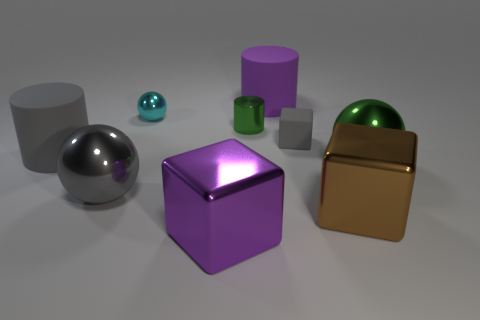Subtract all shiny cubes. How many cubes are left? 1 Subtract all gray cubes. How many cubes are left? 2 Subtract 1 cubes. How many cubes are left? 2 Subtract all blue cubes. Subtract all red spheres. How many cubes are left? 3 Subtract 1 gray spheres. How many objects are left? 8 Subtract all cubes. How many objects are left? 6 Subtract all rubber blocks. Subtract all large gray objects. How many objects are left? 6 Add 8 rubber cubes. How many rubber cubes are left? 9 Add 5 spheres. How many spheres exist? 8 